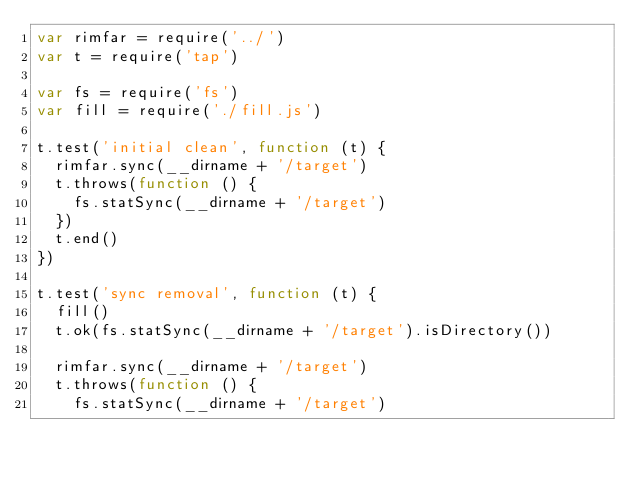<code> <loc_0><loc_0><loc_500><loc_500><_JavaScript_>var rimfar = require('../')
var t = require('tap')

var fs = require('fs')
var fill = require('./fill.js')

t.test('initial clean', function (t) {
  rimfar.sync(__dirname + '/target')
  t.throws(function () {
    fs.statSync(__dirname + '/target')
  })
  t.end()
})

t.test('sync removal', function (t) {
  fill()
  t.ok(fs.statSync(__dirname + '/target').isDirectory())

  rimfar.sync(__dirname + '/target')
  t.throws(function () {
    fs.statSync(__dirname + '/target')</code> 